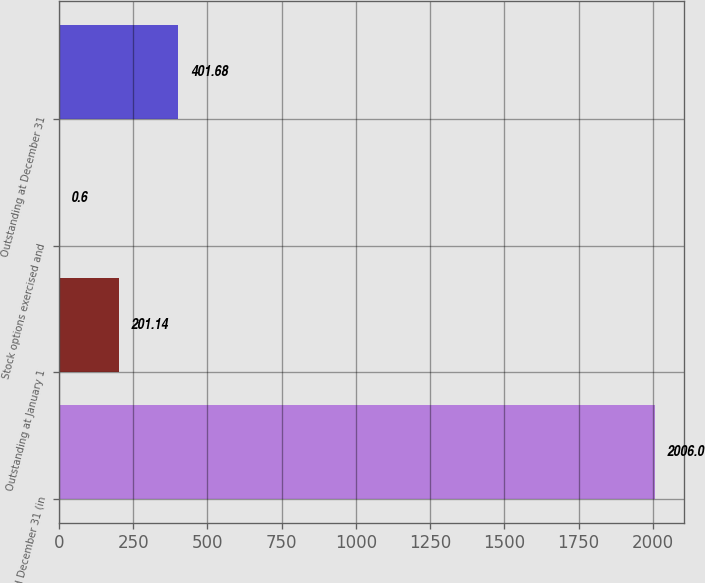Convert chart to OTSL. <chart><loc_0><loc_0><loc_500><loc_500><bar_chart><fcel>Years ended December 31 (in<fcel>Outstanding at January 1<fcel>Stock options exercised and<fcel>Outstanding at December 31<nl><fcel>2006<fcel>201.14<fcel>0.6<fcel>401.68<nl></chart> 